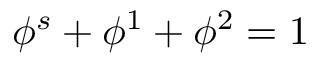<formula> <loc_0><loc_0><loc_500><loc_500>\phi ^ { s } + \phi ^ { 1 } + \phi ^ { 2 } = 1</formula> 